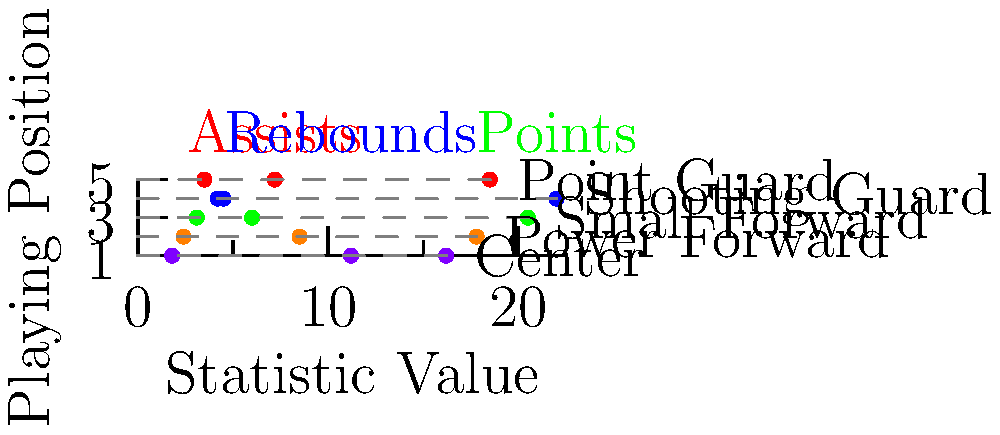Based on the player statistic chart shown, which playing position is most likely to have the highest average number of assists per game? To determine which playing position is most likely to have the highest average number of assists per game, we need to analyze the chart:

1. The chart shows three statistics (assists, rebounds, and points) for five basketball positions.
2. Assists are represented by red dots on the chart.
3. We need to compare the position of the red dots for each playing position:

   - Point Guard: 7.2 assists
   - Shooting Guard: 4.5 assists
   - Small Forward: 3.1 assists
   - Power Forward: 2.4 assists
   - Center: 1.8 assists

4. The Point Guard position has the highest value for assists at 7.2 per game.
5. This aligns with traditional basketball roles, where Point Guards are typically responsible for ball distribution and setting up plays.

Therefore, based on the chart, the Point Guard position is most likely to have the highest average number of assists per game.
Answer: Point Guard 